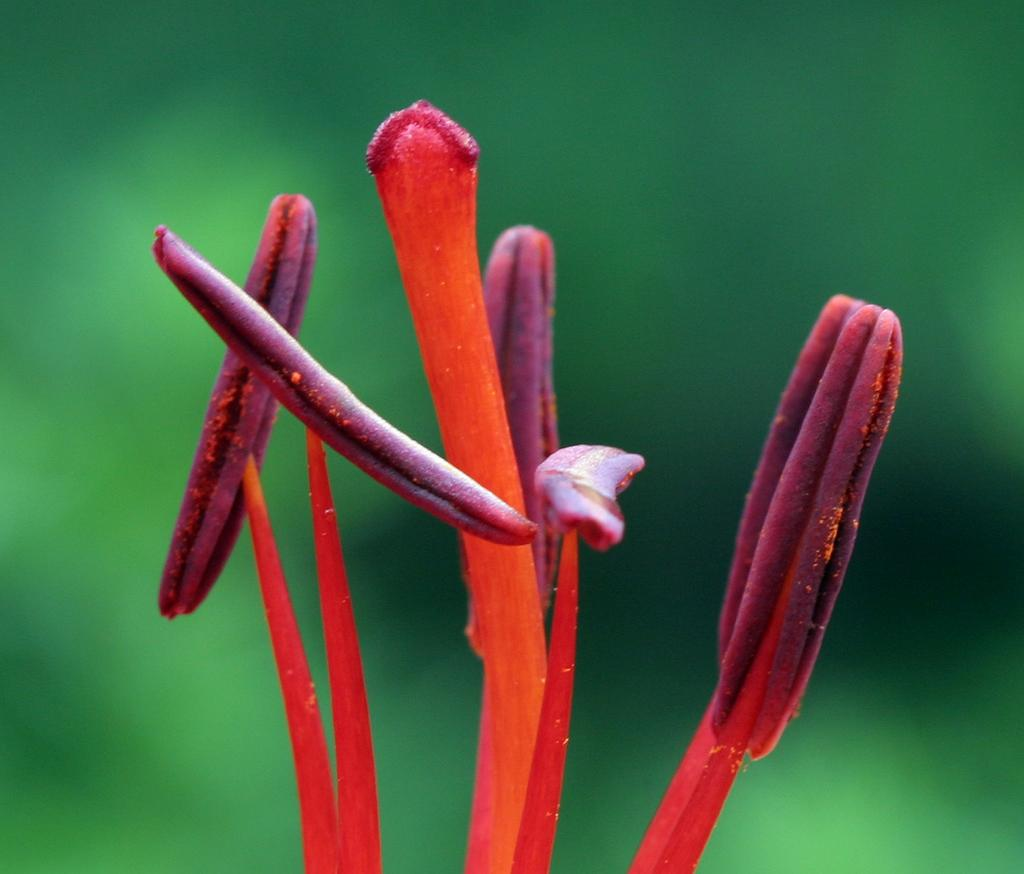What is present in the image? There are buds in the image. Can you describe the background of the image? The background of the image is blurred. What type of sweater is being worn by the buds in the image? There are no people or clothing items present in the image, only buds. 